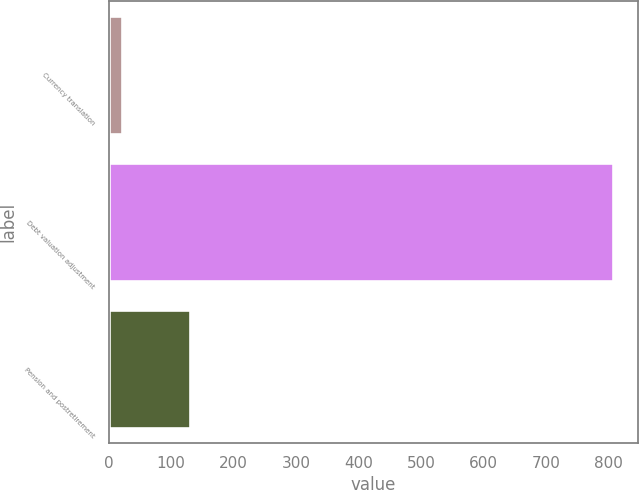<chart> <loc_0><loc_0><loc_500><loc_500><bar_chart><fcel>Currency translation<fcel>Debt valuation adjustment<fcel>Pension and postretirement<nl><fcel>22<fcel>807<fcel>130<nl></chart> 